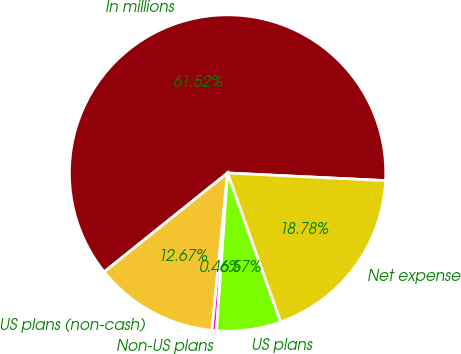<chart> <loc_0><loc_0><loc_500><loc_500><pie_chart><fcel>In millions<fcel>US plans (non-cash)<fcel>Non-US plans<fcel>US plans<fcel>Net expense<nl><fcel>61.52%<fcel>12.67%<fcel>0.46%<fcel>6.57%<fcel>18.78%<nl></chart> 